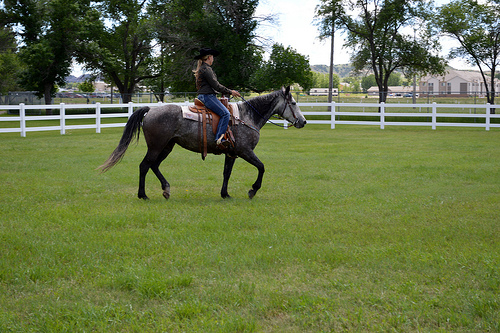<image>
Is there a fence behind the rider? Yes. From this viewpoint, the fence is positioned behind the rider, with the rider partially or fully occluding the fence. Where is the horse in relation to the fence? Is it next to the fence? No. The horse is not positioned next to the fence. They are located in different areas of the scene. 